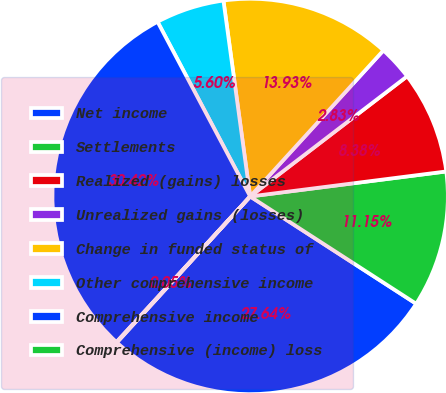<chart> <loc_0><loc_0><loc_500><loc_500><pie_chart><fcel>Net income<fcel>Settlements<fcel>Realized (gains) losses<fcel>Unrealized gains (losses)<fcel>Change in funded status of<fcel>Other comprehensive income<fcel>Comprehensive income<fcel>Comprehensive (income) loss<nl><fcel>27.64%<fcel>11.15%<fcel>8.38%<fcel>2.83%<fcel>13.93%<fcel>5.6%<fcel>30.42%<fcel>0.05%<nl></chart> 